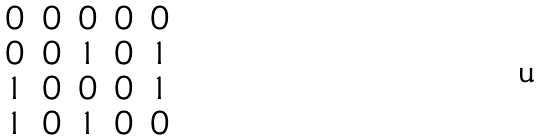Convert formula to latex. <formula><loc_0><loc_0><loc_500><loc_500>\begin{matrix} 0 & 0 & 0 & 0 & 0 \\ 0 & 0 & 1 & 0 & 1 \\ 1 & 0 & 0 & 0 & 1 \\ 1 & 0 & 1 & 0 & 0 \\ \end{matrix}</formula> 